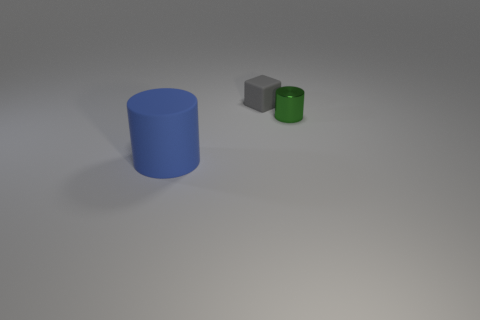Add 2 large cylinders. How many objects exist? 5 Subtract 0 red cylinders. How many objects are left? 3 Subtract all blocks. How many objects are left? 2 Subtract all large blue rubber cylinders. Subtract all tiny objects. How many objects are left? 0 Add 3 small metal cylinders. How many small metal cylinders are left? 4 Add 3 tiny yellow cylinders. How many tiny yellow cylinders exist? 3 